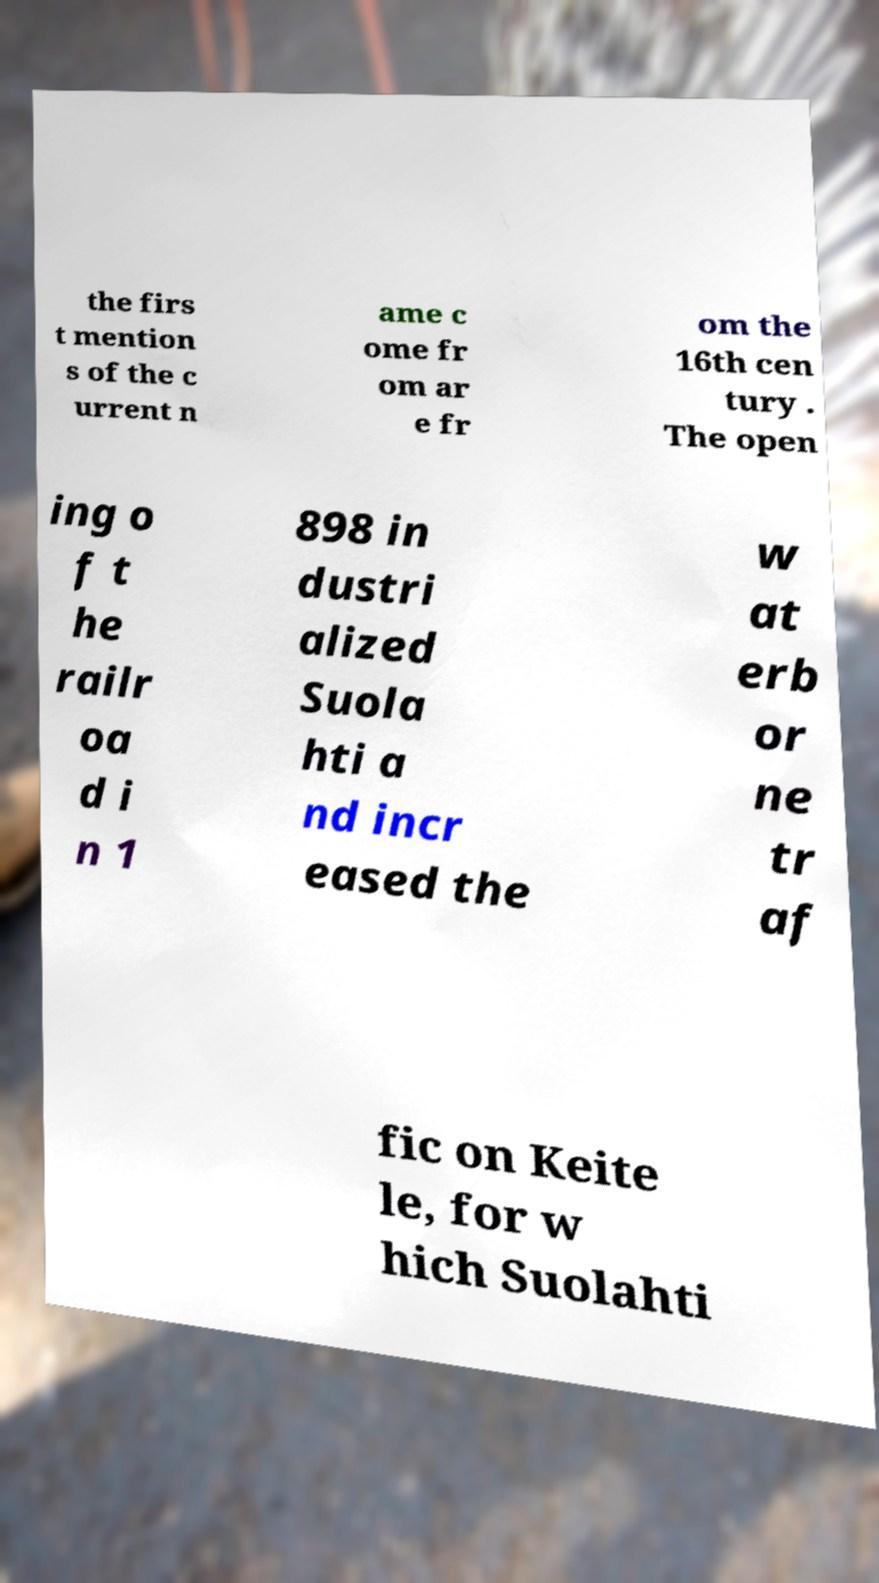Please read and relay the text visible in this image. What does it say? the firs t mention s of the c urrent n ame c ome fr om ar e fr om the 16th cen tury . The open ing o f t he railr oa d i n 1 898 in dustri alized Suola hti a nd incr eased the w at erb or ne tr af fic on Keite le, for w hich Suolahti 